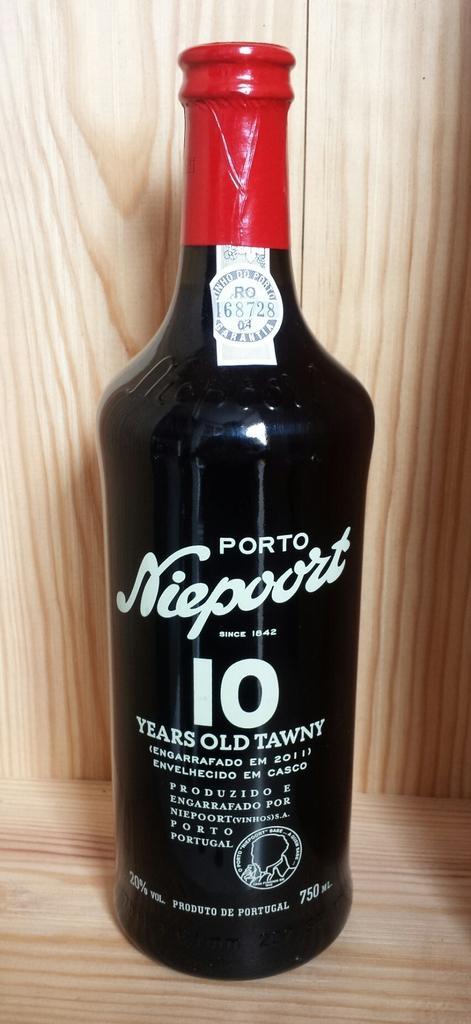Can you describe this image briefly? In this image there is a bottle on the wooden surface. There is some text on the bottle. Background there is a wooden material. 